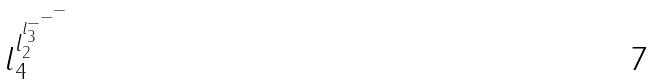Convert formula to latex. <formula><loc_0><loc_0><loc_500><loc_500>l _ { 4 } ^ { l _ { 2 } ^ { l _ { 3 } ^ { - ^ { - ^ { - } } } } }</formula> 